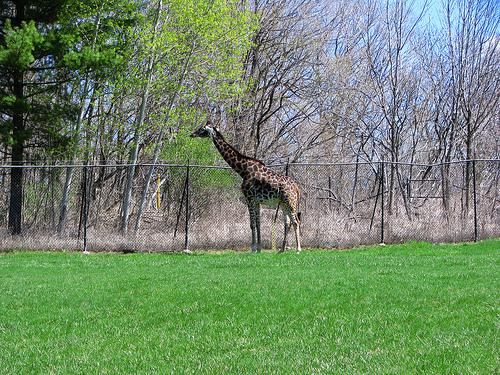Question: who has a long neck?
Choices:
A. Anteater.
B. Giraffe.
C. Kangaroo.
D. Ostrich.
Answer with the letter. Answer: B Question: when was the picture taken?
Choices:
A. Daytime.
B. Sunrise.
C. Night time.
D. Sunset.
Answer with the letter. Answer: A Question: what is brown and beige?
Choices:
A. A paper bag.
B. A shirt.
C. A dog.
D. A giraffe.
Answer with the letter. Answer: D Question: how many giraffe are there?
Choices:
A. 2.
B. 3.
C. 1.
D. 4.
Answer with the letter. Answer: C Question: what has four legs?
Choices:
A. One dog.
B. One cat.
C. One giraffe.
D. One cow.
Answer with the letter. Answer: C Question: what is in the background?
Choices:
A. Sky.
B. Trees.
C. Buildings.
D. The ocean.
Answer with the letter. Answer: B Question: what animal is in the picture?
Choices:
A. A giraffe.
B. Zebra.
C. Elephant.
D. Cow.
Answer with the letter. Answer: A Question: how many giraffes are there?
Choices:
A. 2.
B. 3.
C. 4.
D. 1.
Answer with the letter. Answer: D Question: where was the photo taken?
Choices:
A. In a zoo.
B. By a park.
C. By a school.
D. By the city hall.
Answer with the letter. Answer: A Question: what color is the grass?
Choices:
A. Blue.
B. Green.
C. Yellow.
D. Brown.
Answer with the letter. Answer: B 